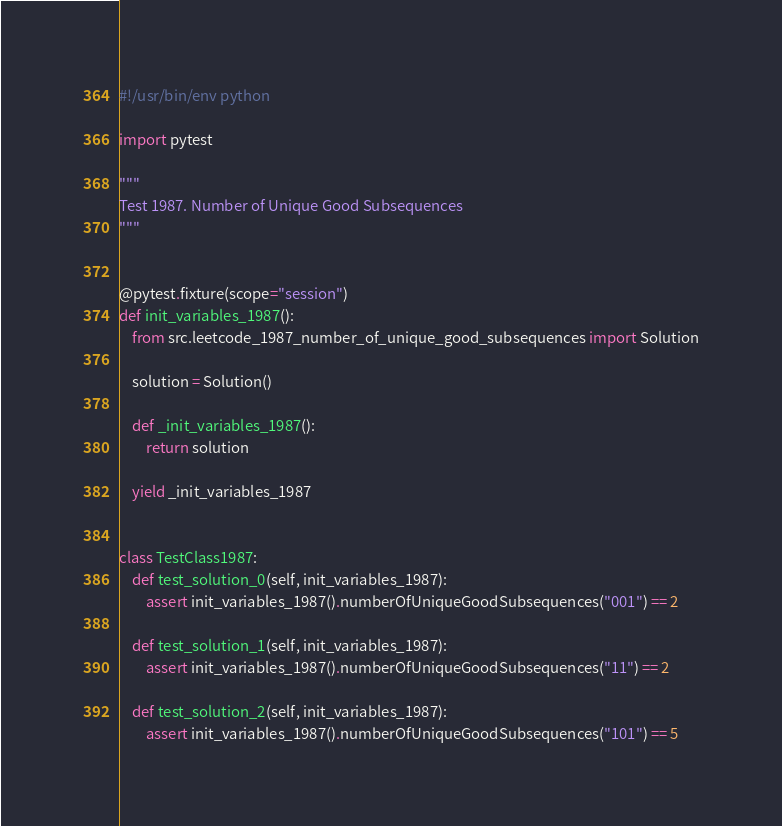Convert code to text. <code><loc_0><loc_0><loc_500><loc_500><_Python_>#!/usr/bin/env python

import pytest

"""
Test 1987. Number of Unique Good Subsequences
"""


@pytest.fixture(scope="session")
def init_variables_1987():
    from src.leetcode_1987_number_of_unique_good_subsequences import Solution

    solution = Solution()

    def _init_variables_1987():
        return solution

    yield _init_variables_1987


class TestClass1987:
    def test_solution_0(self, init_variables_1987):
        assert init_variables_1987().numberOfUniqueGoodSubsequences("001") == 2

    def test_solution_1(self, init_variables_1987):
        assert init_variables_1987().numberOfUniqueGoodSubsequences("11") == 2

    def test_solution_2(self, init_variables_1987):
        assert init_variables_1987().numberOfUniqueGoodSubsequences("101") == 5
</code> 